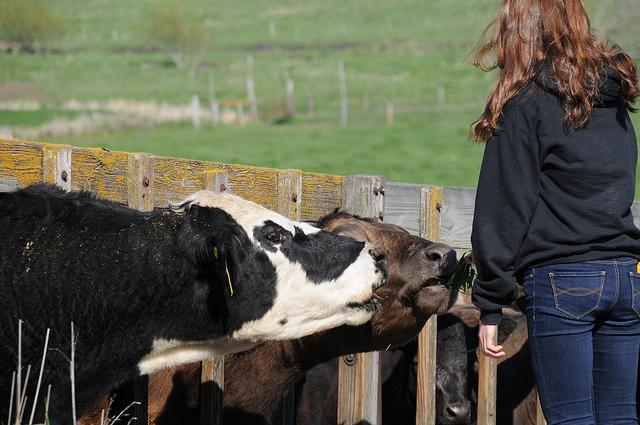Who is the woman feeding the cows?

Choices:
A) farm worker
B) animal rescuer
C) visitor
D) zookeeper visitor 